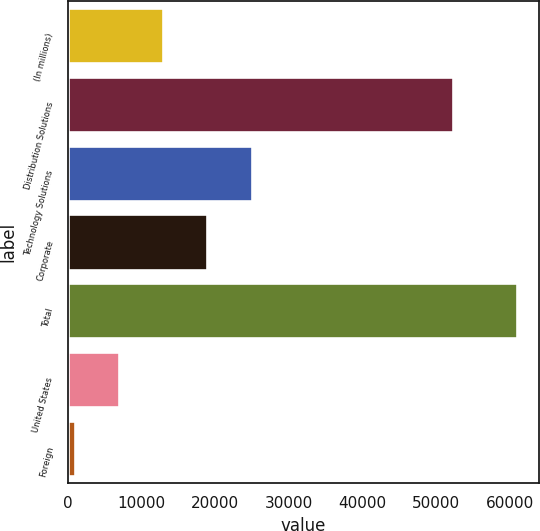Convert chart to OTSL. <chart><loc_0><loc_0><loc_500><loc_500><bar_chart><fcel>(In millions)<fcel>Distribution Solutions<fcel>Technology Solutions<fcel>Corporate<fcel>Total<fcel>United States<fcel>Foreign<nl><fcel>12921<fcel>52322<fcel>24933<fcel>18927<fcel>60969<fcel>6915<fcel>909<nl></chart> 